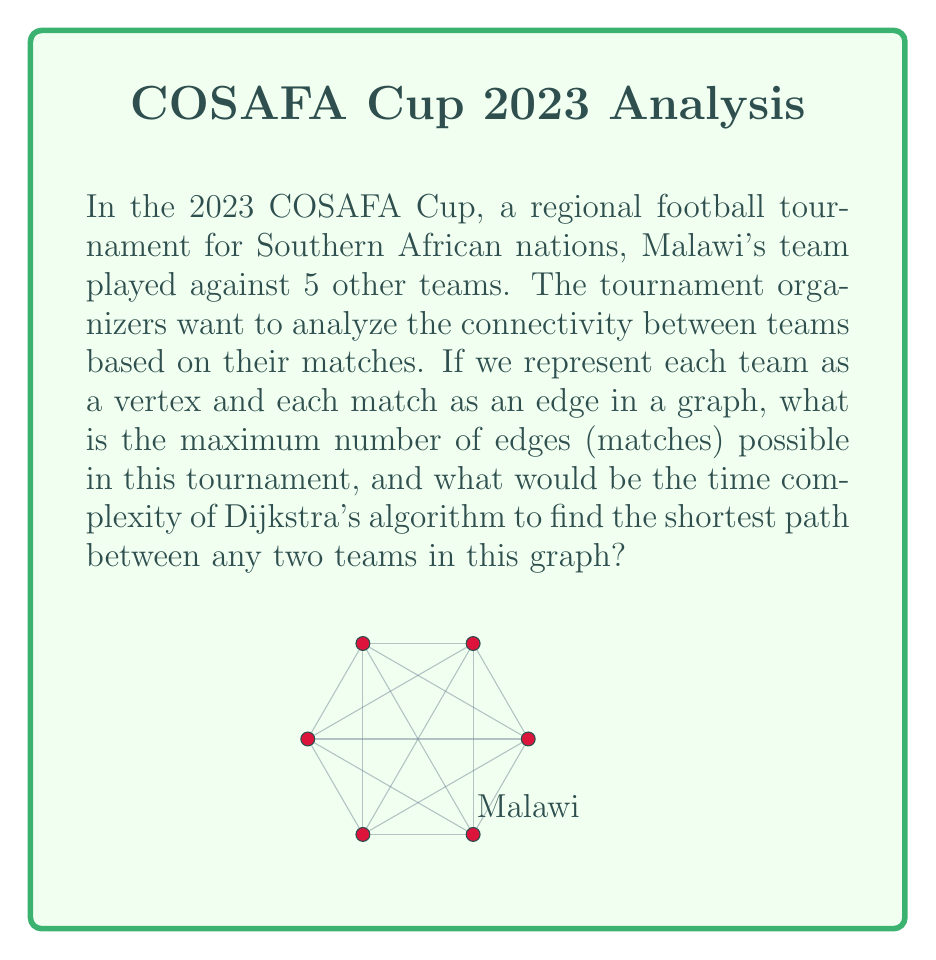Could you help me with this problem? Let's approach this step-by-step:

1) First, we need to calculate the maximum number of edges in the graph:
   - There are 6 teams in total (Malawi and 5 others)
   - In a complete graph, each team would play against every other team once
   - The number of edges in a complete graph is given by the formula:
     $$ E = \frac{n(n-1)}{2} $$
     where $n$ is the number of vertices (teams)
   - Substituting $n = 6$:
     $$ E = \frac{6(6-1)}{2} = \frac{6 \times 5}{2} = 15 $$

2) Now, for Dijkstra's algorithm:
   - The time complexity of Dijkstra's algorithm depends on how the priority queue is implemented
   - Using a binary heap, the time complexity is:
     $$ O((V + E) \log V) $$
     where $V$ is the number of vertices and $E$ is the number of edges
   - In our case, $V = 6$ and $E_{max} = 15$
   - Substituting these values:
     $$ O((6 + 15) \log 6) = O(21 \log 6) $$

3) Simplifying:
   - $\log 6 \approx 2.58$ (rounded to 2 decimal places)
   - $O(21 \times 2.58) \approx O(54.18)$
   - In Big O notation, we drop constants, so the final time complexity is $O(\log V)$

Therefore, the maximum number of edges is 15, and the time complexity of Dijkstra's algorithm on this graph would be $O(\log V)$.
Answer: 15 edges; $O(\log V)$ 